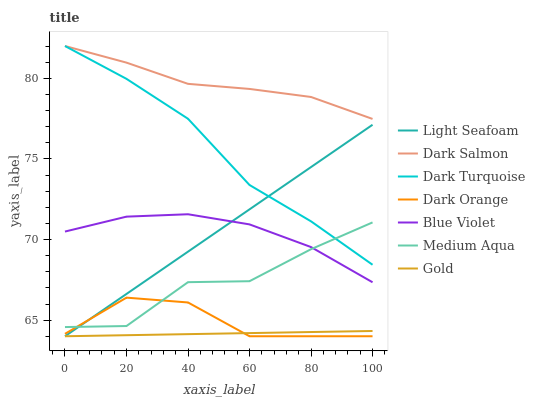Does Dark Turquoise have the minimum area under the curve?
Answer yes or no. No. Does Dark Turquoise have the maximum area under the curve?
Answer yes or no. No. Is Dark Turquoise the smoothest?
Answer yes or no. No. Is Dark Turquoise the roughest?
Answer yes or no. No. Does Dark Turquoise have the lowest value?
Answer yes or no. No. Does Gold have the highest value?
Answer yes or no. No. Is Gold less than Blue Violet?
Answer yes or no. Yes. Is Dark Salmon greater than Light Seafoam?
Answer yes or no. Yes. Does Gold intersect Blue Violet?
Answer yes or no. No. 